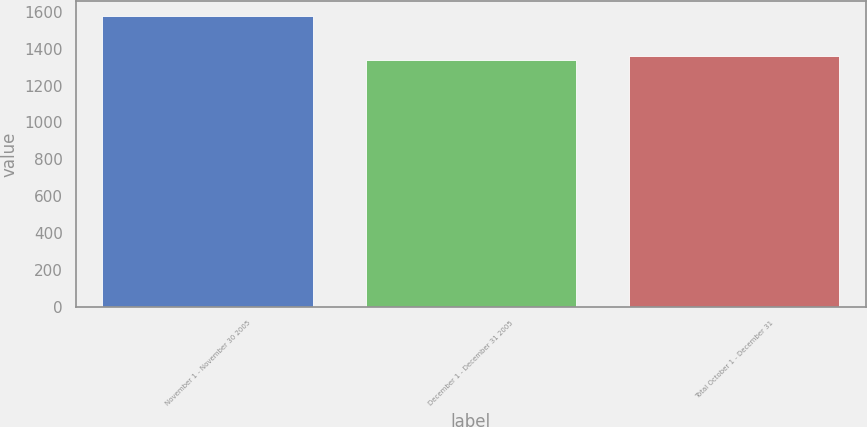Convert chart to OTSL. <chart><loc_0><loc_0><loc_500><loc_500><bar_chart><fcel>November 1 - November 30 2005<fcel>December 1 - December 31 2005<fcel>Total October 1 - December 31<nl><fcel>1578<fcel>1338<fcel>1362<nl></chart> 